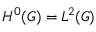<formula> <loc_0><loc_0><loc_500><loc_500>H ^ { 0 } ( G ) = L ^ { 2 } ( G )</formula> 